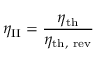Convert formula to latex. <formula><loc_0><loc_0><loc_500><loc_500>\eta _ { I I } = { \frac { \eta _ { t h } } { \eta _ { t h , r e v } } }</formula> 